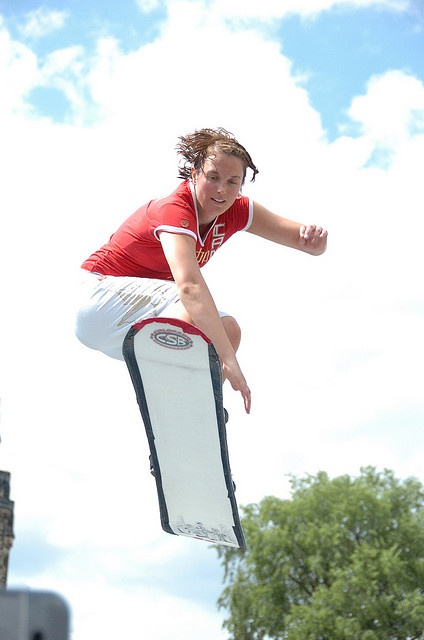Describe the objects in this image and their specific colors. I can see people in lightblue, white, gray, lightpink, and darkgray tones and snowboard in lightblue, lightgray, gray, blue, and darkgray tones in this image. 